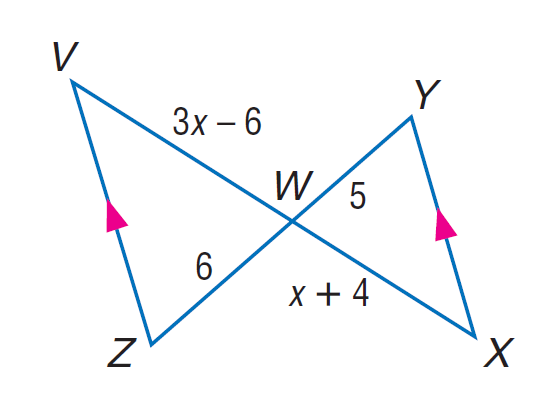Question: Find W X.
Choices:
A. 6
B. 8
C. 10
D. 12
Answer with the letter. Answer: C 